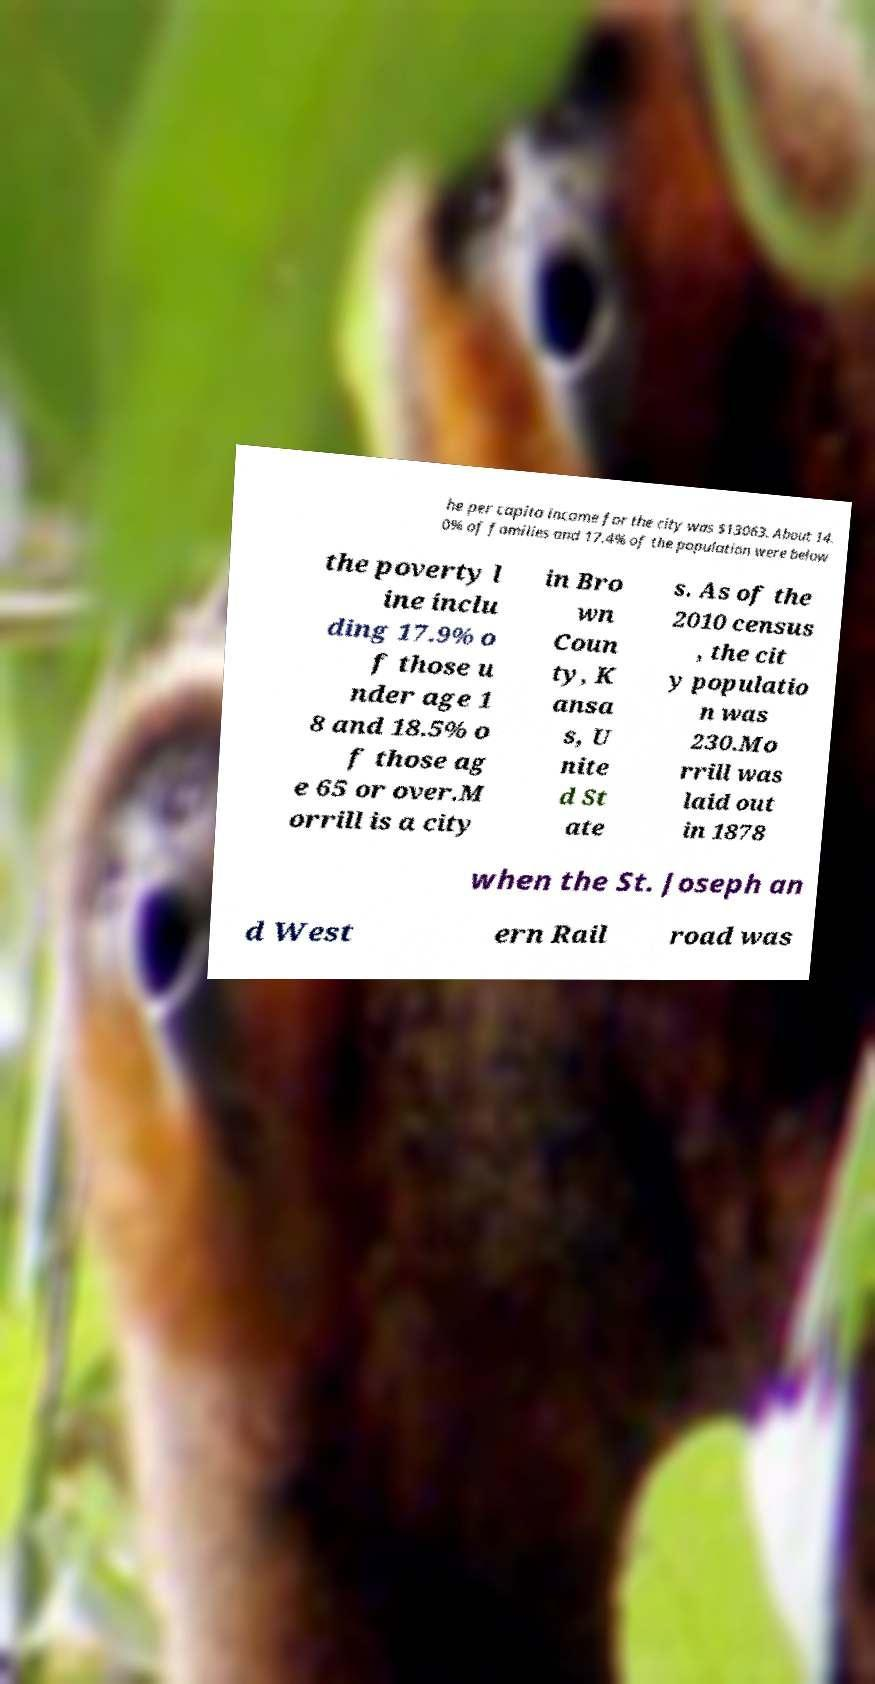Please identify and transcribe the text found in this image. he per capita income for the city was $13063. About 14. 0% of families and 17.4% of the population were below the poverty l ine inclu ding 17.9% o f those u nder age 1 8 and 18.5% o f those ag e 65 or over.M orrill is a city in Bro wn Coun ty, K ansa s, U nite d St ate s. As of the 2010 census , the cit y populatio n was 230.Mo rrill was laid out in 1878 when the St. Joseph an d West ern Rail road was 